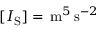Convert formula to latex. <formula><loc_0><loc_0><loc_500><loc_500>[ I _ { S } ] = \, m ^ { 5 } \, s ^ { - 2 }</formula> 